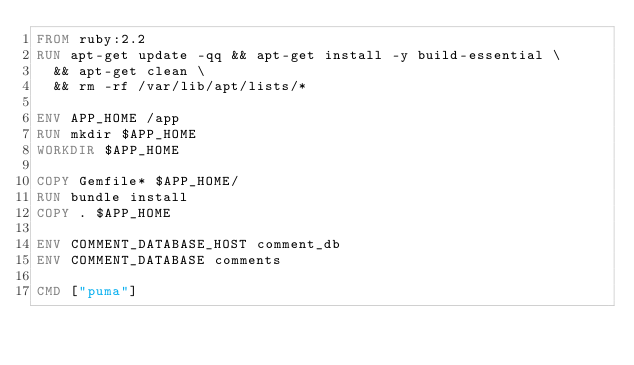<code> <loc_0><loc_0><loc_500><loc_500><_Dockerfile_>FROM ruby:2.2
RUN apt-get update -qq && apt-get install -y build-essential \
  && apt-get clean \
  && rm -rf /var/lib/apt/lists/*

ENV APP_HOME /app
RUN mkdir $APP_HOME
WORKDIR $APP_HOME

COPY Gemfile* $APP_HOME/
RUN bundle install
COPY . $APP_HOME

ENV COMMENT_DATABASE_HOST comment_db
ENV COMMENT_DATABASE comments

CMD ["puma"]
</code> 